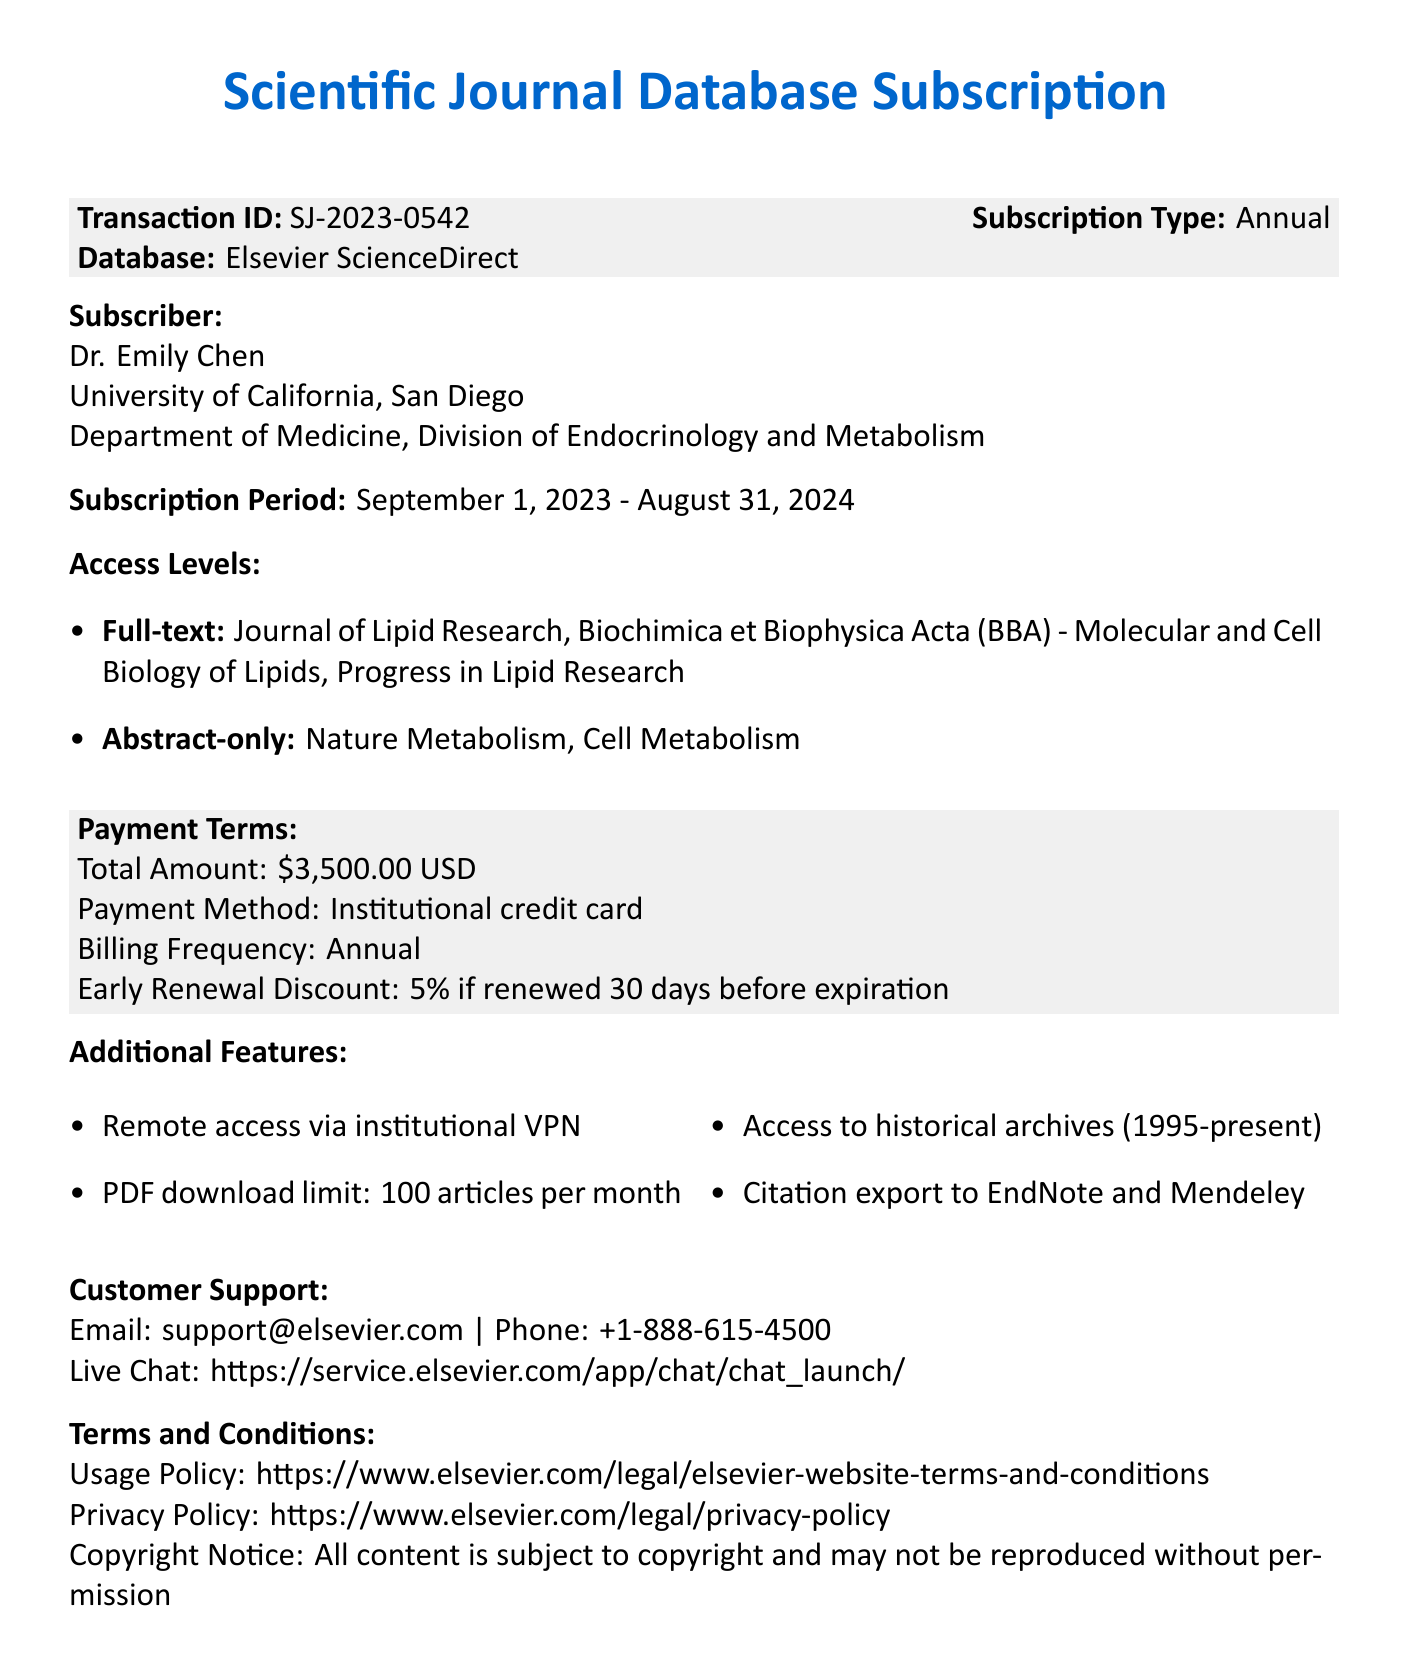What is the transaction ID? The transaction ID is a unique identifier for the subscription as shown in the document.
Answer: SJ-2023-0542 Who is the subscriber? The subscriber's name is provided in the document under the section for Subscriber.
Answer: Dr. Emily Chen What is the total amount for the subscription? The total amount is stated in the Payment Terms section of the document.
Answer: 3500.00 USD What are the full-text access journals? The document lists the journals available with full-text access in the Access Levels section.
Answer: Journal of Lipid Research, Biochimica et Biophysica Acta (BBA) - Molecular and Cell Biology of Lipids, Progress in Lipid Research What is the early renewal discount? The amount of discount offered for early renewal is stated in the Payment Terms section.
Answer: 5% if renewed 30 days before expiration What is the billing frequency? The billing frequency is provided as part of the Payment Terms in the document.
Answer: Annual What is the subscription period? The subscription period indicates the start and end dates of the subscription stated in the document.
Answer: September 1, 2023 - August 31, 2024 How many articles can be downloaded per month? The limit on article downloads per month is specified in the Additional Features section.
Answer: 100 articles per month What is the email for customer support? The email for customer support is listed in the Customer Support section of this document.
Answer: support@elsevier.com 